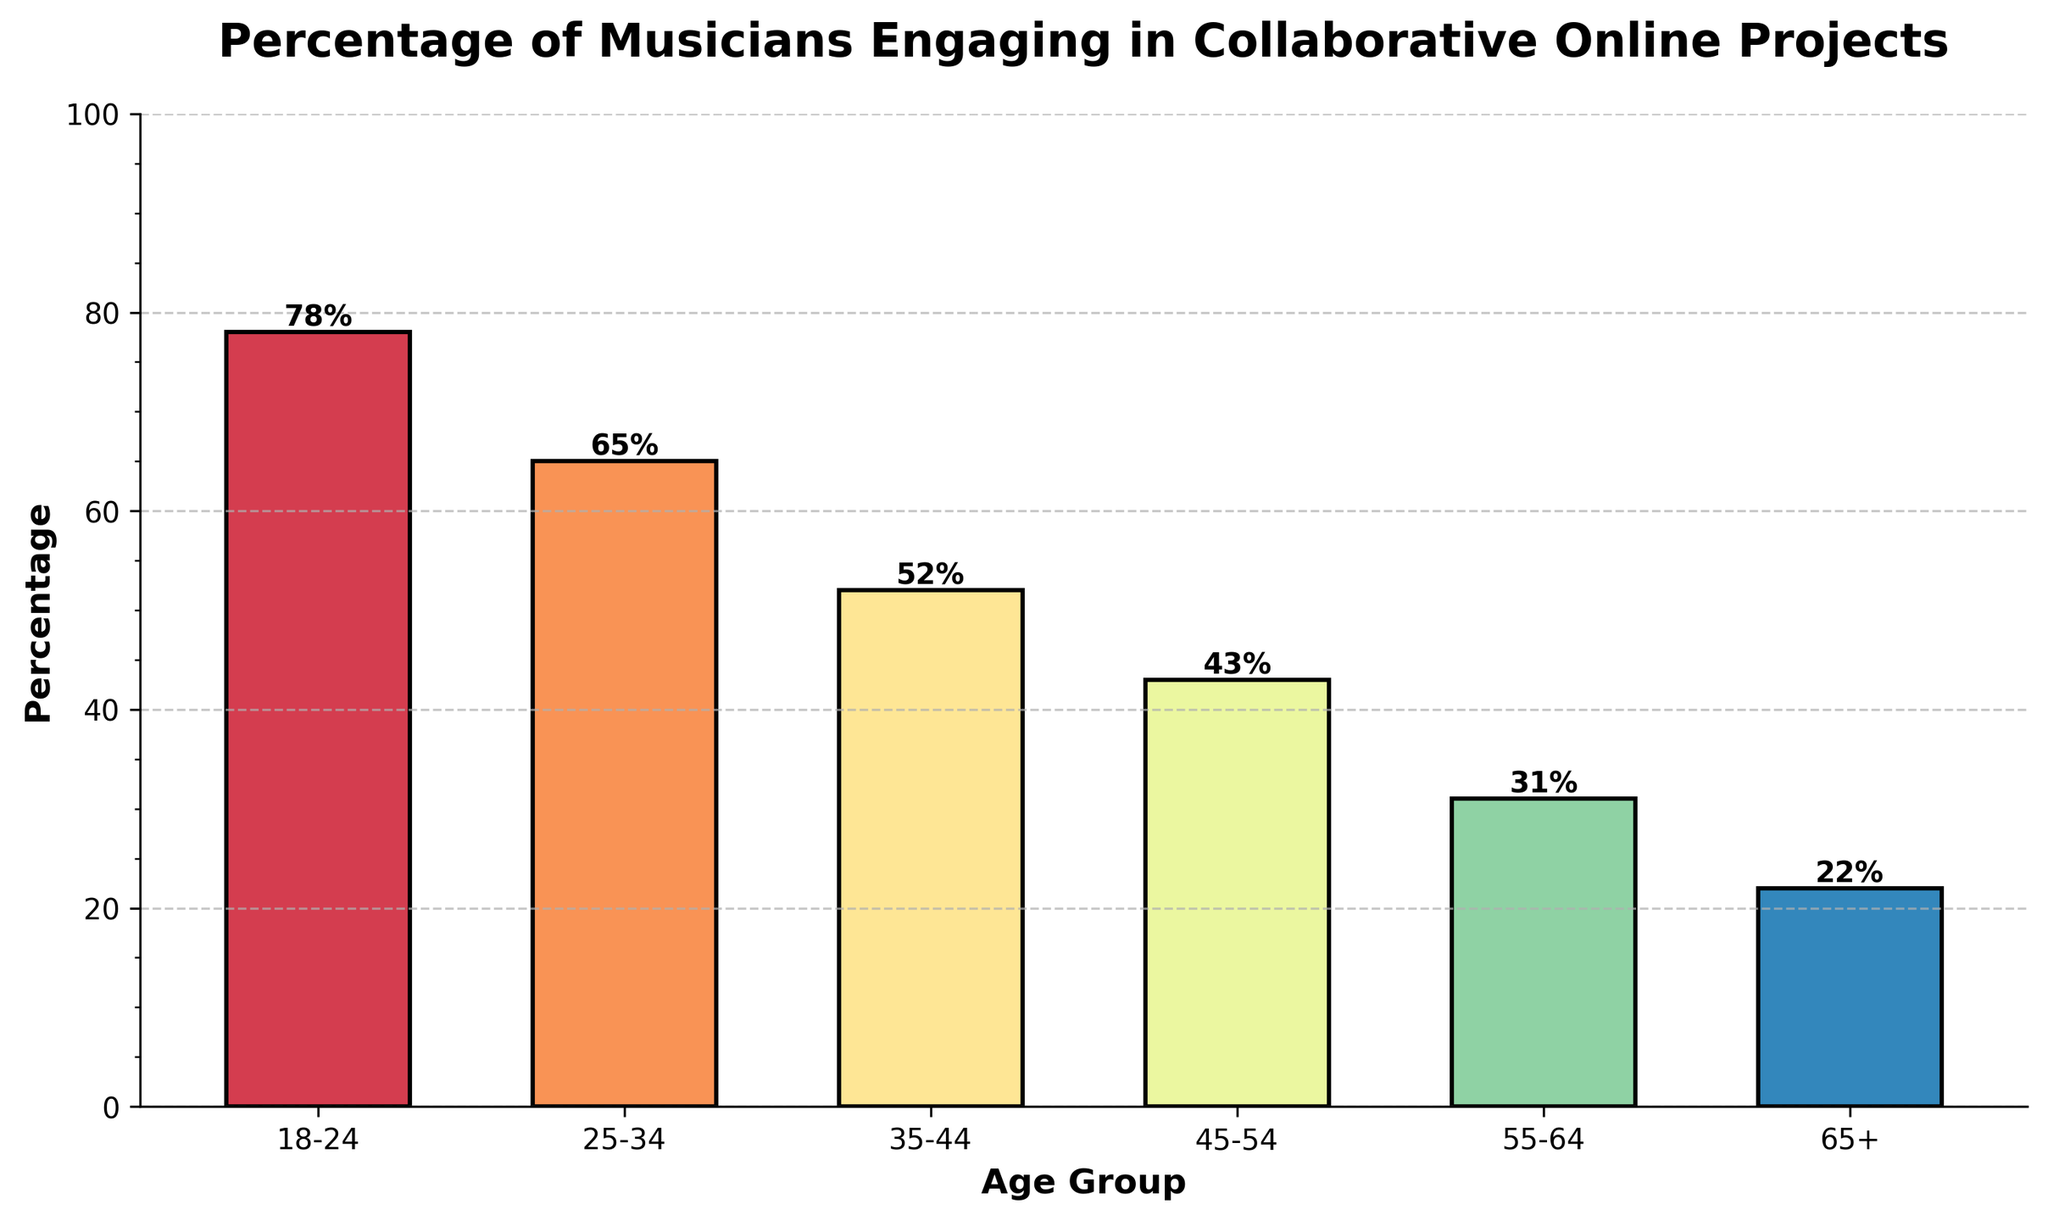What age group has the highest percentage of musicians who engage in collaborative online projects? In the bar chart, the age group 18–24 has the highest bar, indicating the highest percentage among all age groups.
Answer: 18-24 Which age group shows the smallest percentage of musicians involved in collaborative online projects? The age group 65+ has the shortest bar in the chart, signifying the smallest percentage.
Answer: 65+ What is the percentage difference between the age groups 18-24 and 55-64? The percentage for 18-24 is 78% and for 55-64 is 31%. The difference is calculated as 78% - 31% = 47%.
Answer: 47% Compare the percentages of age groups 25-34 and 35-44. Which age group has a higher percentage, and by how much? The percentage for 25-34 is 65% and for 35-44 is 52%. 65% - 52% = 13%, so 25-34 has a higher percentage by 13%.
Answer: 25-34, by 13% What is the average percentage of musicians involved in collaborative online projects for age groups 45-54, 55-64, and 65+? The percentages are 43%, 31%, and 22%. To find the average: (43 + 31 + 22)/3 = 32.
Answer: 32 Which two adjacent age groups have the smallest difference in their percentages? Comparing differences between adjacent age groups: 18-24 and 25-34 = 13%, 25-34 and 35-44 = 13%, 35-44 and 45-54 = 9%, 45-54 and 55-64 = 12%, 55-64 and 65+ = 9%. The smallest difference is 9%.
Answer: 35-44 and 45-54, 55-64 and 65+ How many age groups have a percentage above 50%? By observing the bars in the chart, the age groups 18-24, 25-34, and 35-44 have percentages above 50%. There are three such groups.
Answer: 3 Which age group shows a percentage equal to or below the midpoint (50%) of the y-axis? The age groups 35-44, 45-54, 55-64, and 65+ all show percentages at or below 50% as indicated by their bar heights relative to the midpoint.
Answer: 35-44, 45-54, 55-64, 65+ Describe the color differences among the bars representing different age groups in the chart. The bars have different colors ranging from shades like red to blue, representing different percentages visually. Each bar is distinct in color to represent each age group clearly.
Answer: Different shades (red, blue, etc.) What is the total percentage sum of all age groups combined? Adding the percentages of all age groups: 78% + 65% + 52% + 43% + 31% + 22% = 291%.
Answer: 291% 